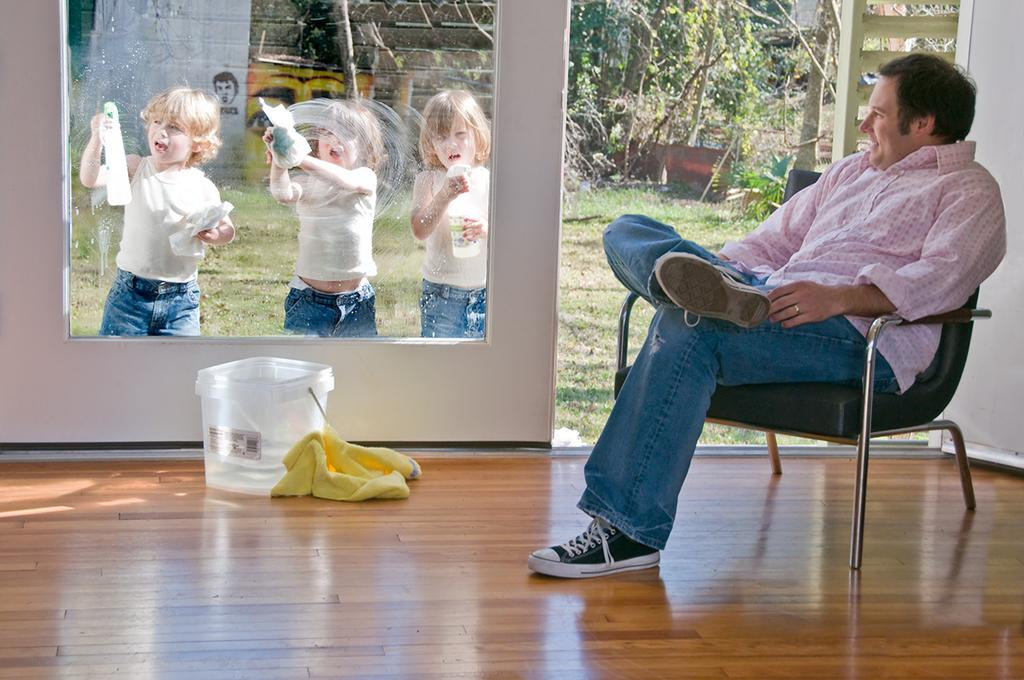Where is the person sitting in the room? The person is sitting on the right side of the room. What are the other people in the room doing? There are three people cleaning the glass behind the person. What can be seen in the background of the room? Many trees are visible in the background. How does the person sitting on the right side of the room plan to ride the bike in the image? There is no bike present in the image, so the person cannot ride a bike. 